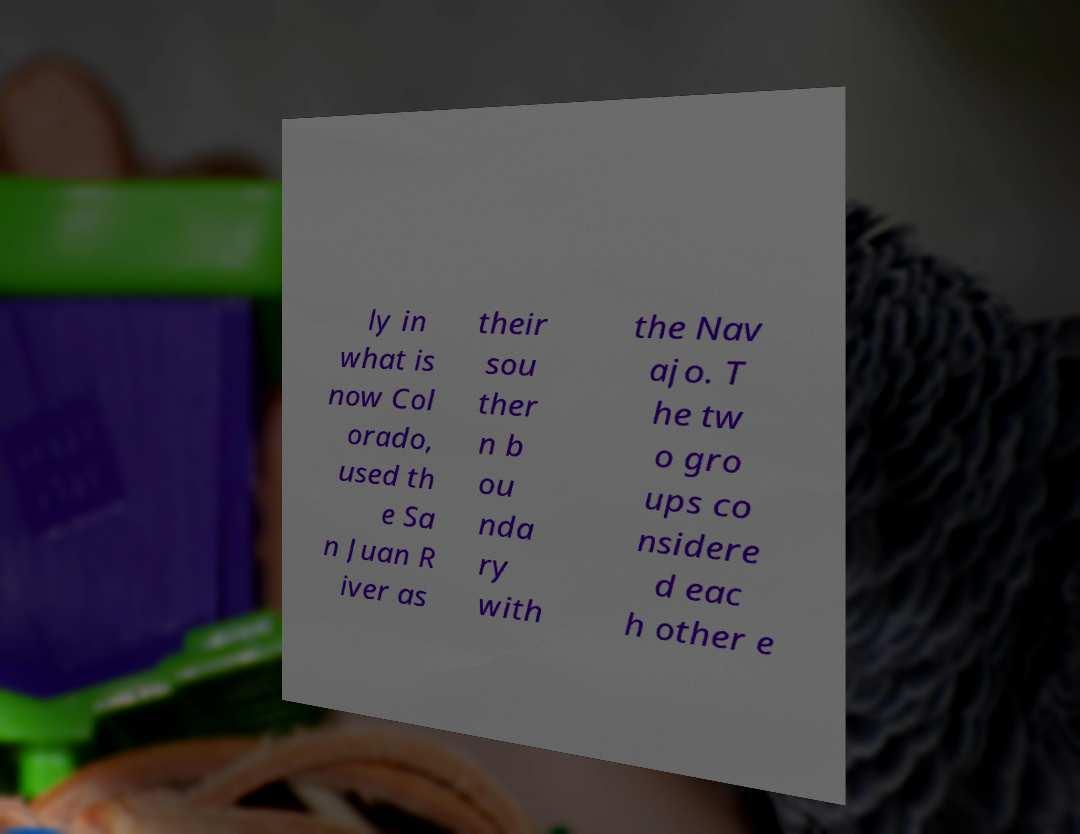Could you assist in decoding the text presented in this image and type it out clearly? ly in what is now Col orado, used th e Sa n Juan R iver as their sou ther n b ou nda ry with the Nav ajo. T he tw o gro ups co nsidere d eac h other e 